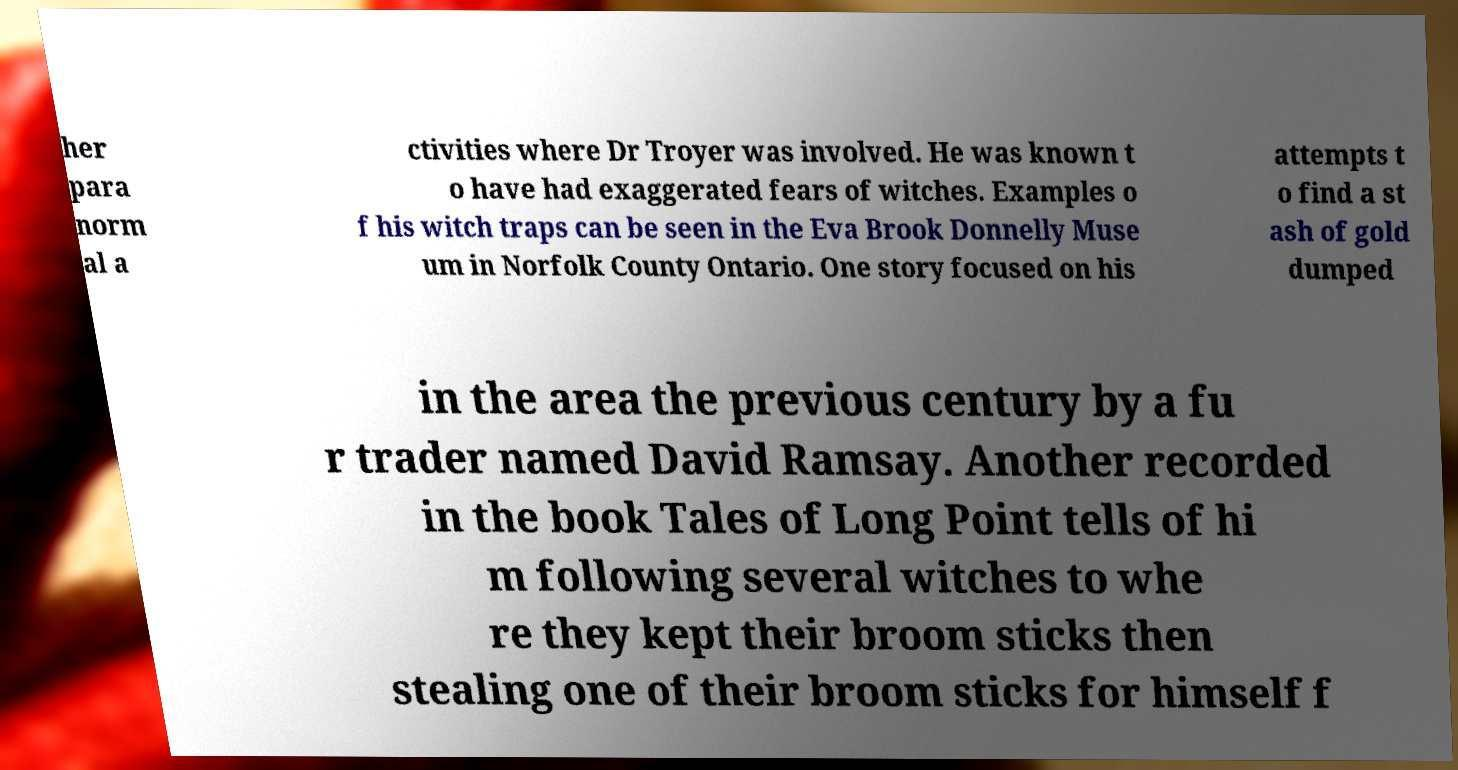Can you accurately transcribe the text from the provided image for me? her para norm al a ctivities where Dr Troyer was involved. He was known t o have had exaggerated fears of witches. Examples o f his witch traps can be seen in the Eva Brook Donnelly Muse um in Norfolk County Ontario. One story focused on his attempts t o find a st ash of gold dumped in the area the previous century by a fu r trader named David Ramsay. Another recorded in the book Tales of Long Point tells of hi m following several witches to whe re they kept their broom sticks then stealing one of their broom sticks for himself f 